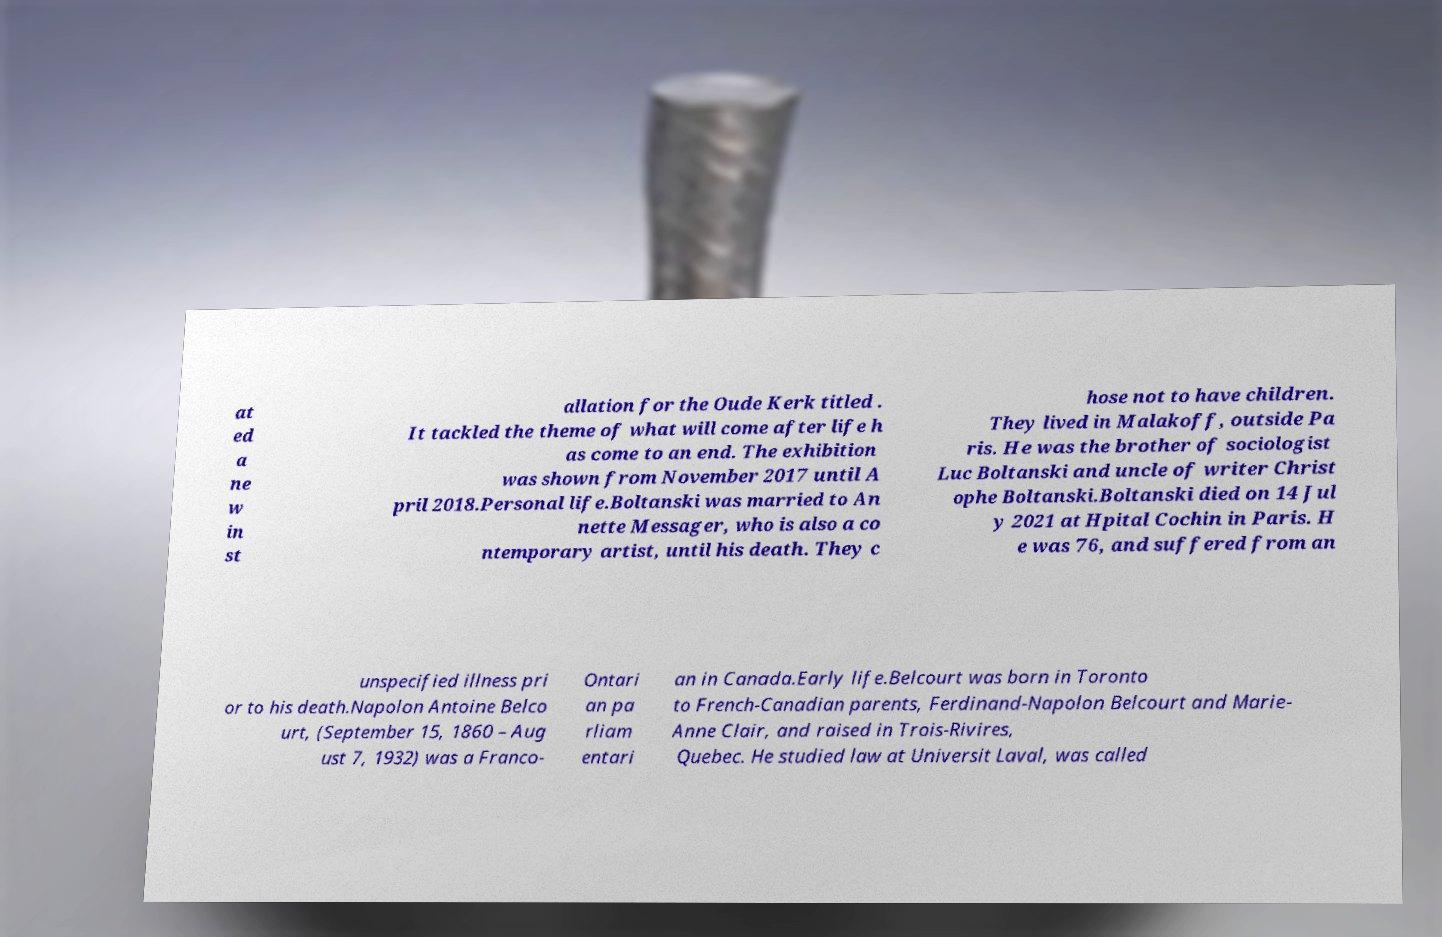I need the written content from this picture converted into text. Can you do that? at ed a ne w in st allation for the Oude Kerk titled . It tackled the theme of what will come after life h as come to an end. The exhibition was shown from November 2017 until A pril 2018.Personal life.Boltanski was married to An nette Messager, who is also a co ntemporary artist, until his death. They c hose not to have children. They lived in Malakoff, outside Pa ris. He was the brother of sociologist Luc Boltanski and uncle of writer Christ ophe Boltanski.Boltanski died on 14 Jul y 2021 at Hpital Cochin in Paris. H e was 76, and suffered from an unspecified illness pri or to his death.Napolon Antoine Belco urt, (September 15, 1860 – Aug ust 7, 1932) was a Franco- Ontari an pa rliam entari an in Canada.Early life.Belcourt was born in Toronto to French-Canadian parents, Ferdinand-Napolon Belcourt and Marie- Anne Clair, and raised in Trois-Rivires, Quebec. He studied law at Universit Laval, was called 